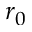<formula> <loc_0><loc_0><loc_500><loc_500>r _ { 0 }</formula> 